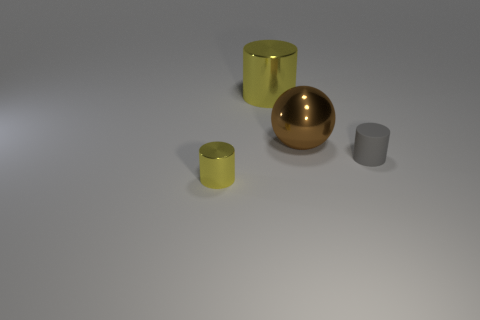Could you estimate the relative sizes of these objects? Certainly. Based on the image, the large golden sphere appears to be the largest object; I would estimate its diameter to be roughly twice the height of the small gray cylinder. The yellow cylinder seems to be slightly taller than the small gray cylinder but with a similar diameter. The gray cube appears to be the smallest object in terms of height and width. 